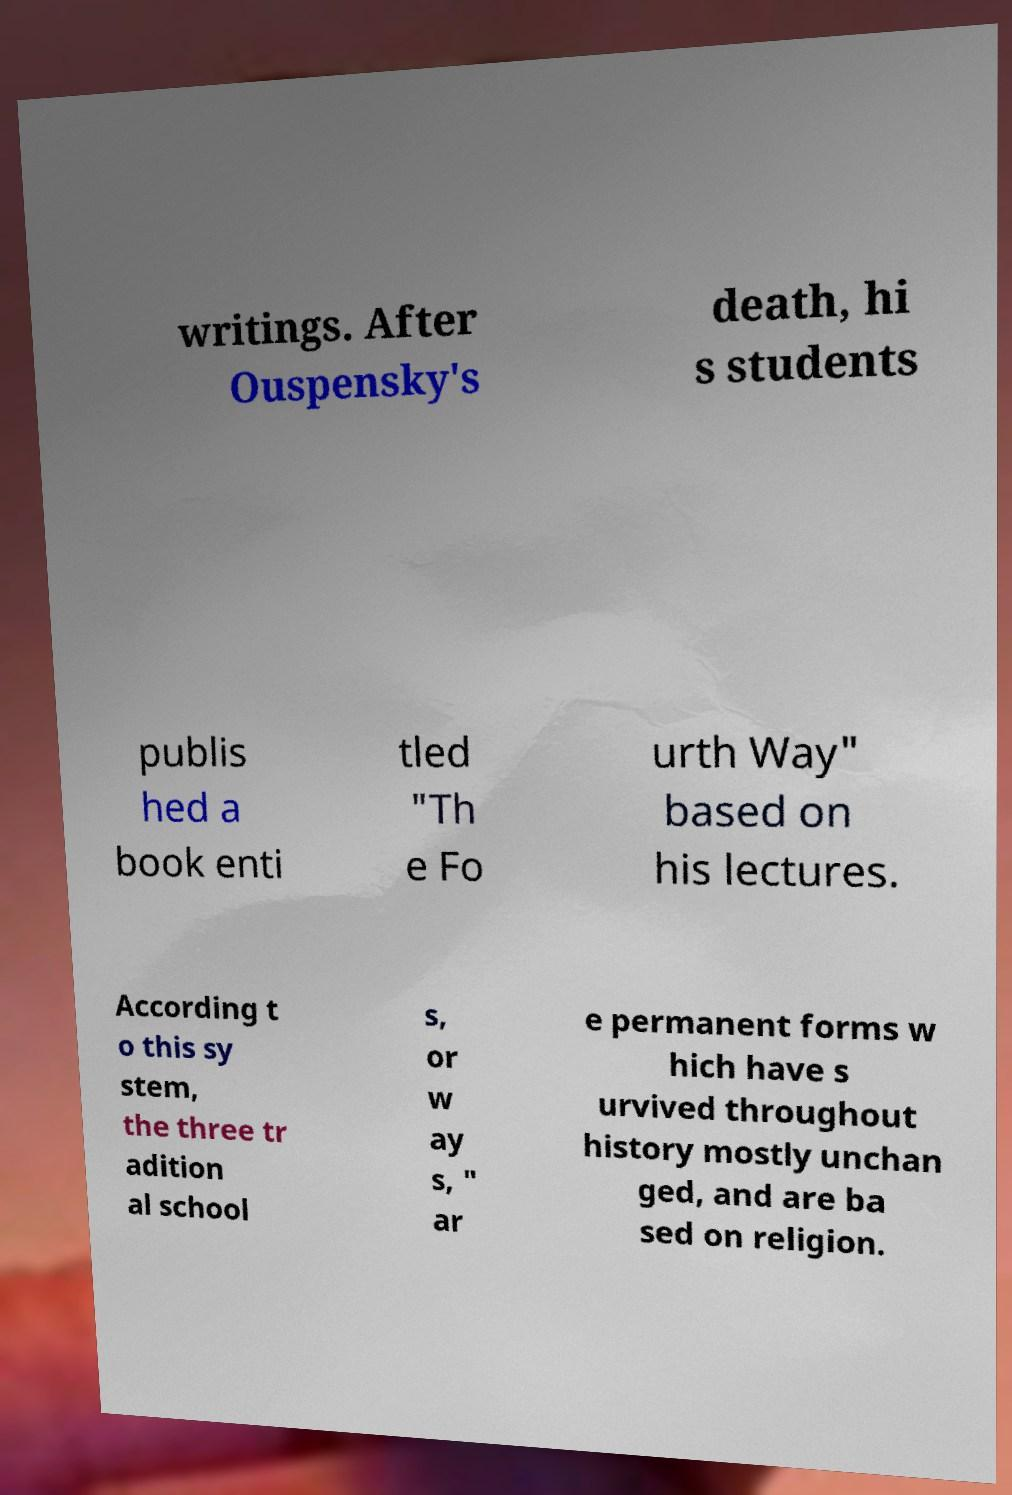Please identify and transcribe the text found in this image. writings. After Ouspensky's death, hi s students publis hed a book enti tled "Th e Fo urth Way" based on his lectures. According t o this sy stem, the three tr adition al school s, or w ay s, " ar e permanent forms w hich have s urvived throughout history mostly unchan ged, and are ba sed on religion. 